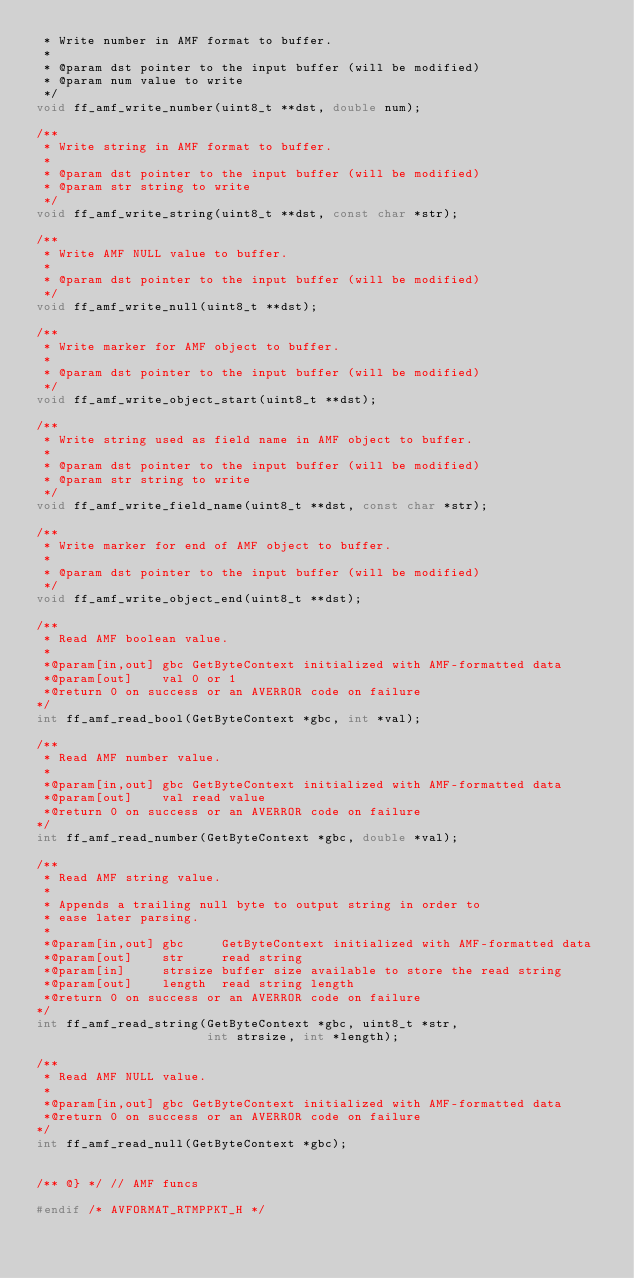<code> <loc_0><loc_0><loc_500><loc_500><_C_> * Write number in AMF format to buffer.
 *
 * @param dst pointer to the input buffer (will be modified)
 * @param num value to write
 */
void ff_amf_write_number(uint8_t **dst, double num);

/**
 * Write string in AMF format to buffer.
 *
 * @param dst pointer to the input buffer (will be modified)
 * @param str string to write
 */
void ff_amf_write_string(uint8_t **dst, const char *str);

/**
 * Write AMF NULL value to buffer.
 *
 * @param dst pointer to the input buffer (will be modified)
 */
void ff_amf_write_null(uint8_t **dst);

/**
 * Write marker for AMF object to buffer.
 *
 * @param dst pointer to the input buffer (will be modified)
 */
void ff_amf_write_object_start(uint8_t **dst);

/**
 * Write string used as field name in AMF object to buffer.
 *
 * @param dst pointer to the input buffer (will be modified)
 * @param str string to write
 */
void ff_amf_write_field_name(uint8_t **dst, const char *str);

/**
 * Write marker for end of AMF object to buffer.
 *
 * @param dst pointer to the input buffer (will be modified)
 */
void ff_amf_write_object_end(uint8_t **dst);

/**
 * Read AMF boolean value.
 *
 *@param[in,out] gbc GetByteContext initialized with AMF-formatted data
 *@param[out]    val 0 or 1
 *@return 0 on success or an AVERROR code on failure
*/
int ff_amf_read_bool(GetByteContext *gbc, int *val);

/**
 * Read AMF number value.
 *
 *@param[in,out] gbc GetByteContext initialized with AMF-formatted data
 *@param[out]    val read value
 *@return 0 on success or an AVERROR code on failure
*/
int ff_amf_read_number(GetByteContext *gbc, double *val);

/**
 * Read AMF string value.
 *
 * Appends a trailing null byte to output string in order to
 * ease later parsing.
 *
 *@param[in,out] gbc     GetByteContext initialized with AMF-formatted data
 *@param[out]    str     read string
 *@param[in]     strsize buffer size available to store the read string
 *@param[out]    length  read string length
 *@return 0 on success or an AVERROR code on failure
*/
int ff_amf_read_string(GetByteContext *gbc, uint8_t *str,
                       int strsize, int *length);

/**
 * Read AMF NULL value.
 *
 *@param[in,out] gbc GetByteContext initialized with AMF-formatted data
 *@return 0 on success or an AVERROR code on failure
*/
int ff_amf_read_null(GetByteContext *gbc);


/** @} */ // AMF funcs

#endif /* AVFORMAT_RTMPPKT_H */
</code> 